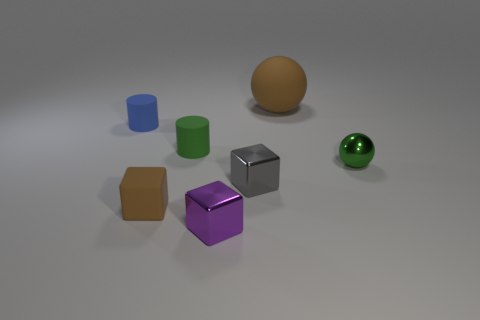If these objects represented a family, which one would be the parent and which ones the children? If we use size as a metaphor for age or parental status, the golden sphere could be seen as the parent due to its larger size, while the smaller colored cubes and the green sphere could represent the children. 